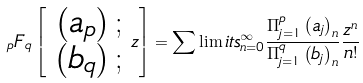Convert formula to latex. <formula><loc_0><loc_0><loc_500><loc_500>_ { p } F _ { q } \left [ \begin{array} { r } \left ( a _ { p } \right ) ; \\ \left ( b _ { q } \right ) ; \end{array} z \right ] = \sum \lim i t s _ { n = 0 } ^ { \infty } \frac { \Pi _ { j = 1 } ^ { p } \left ( a _ { j } \right ) _ { n } } { \Pi _ { j = 1 } ^ { q } \left ( b _ { j } \right ) _ { n } } \frac { z ^ { n } } { n ! }</formula> 